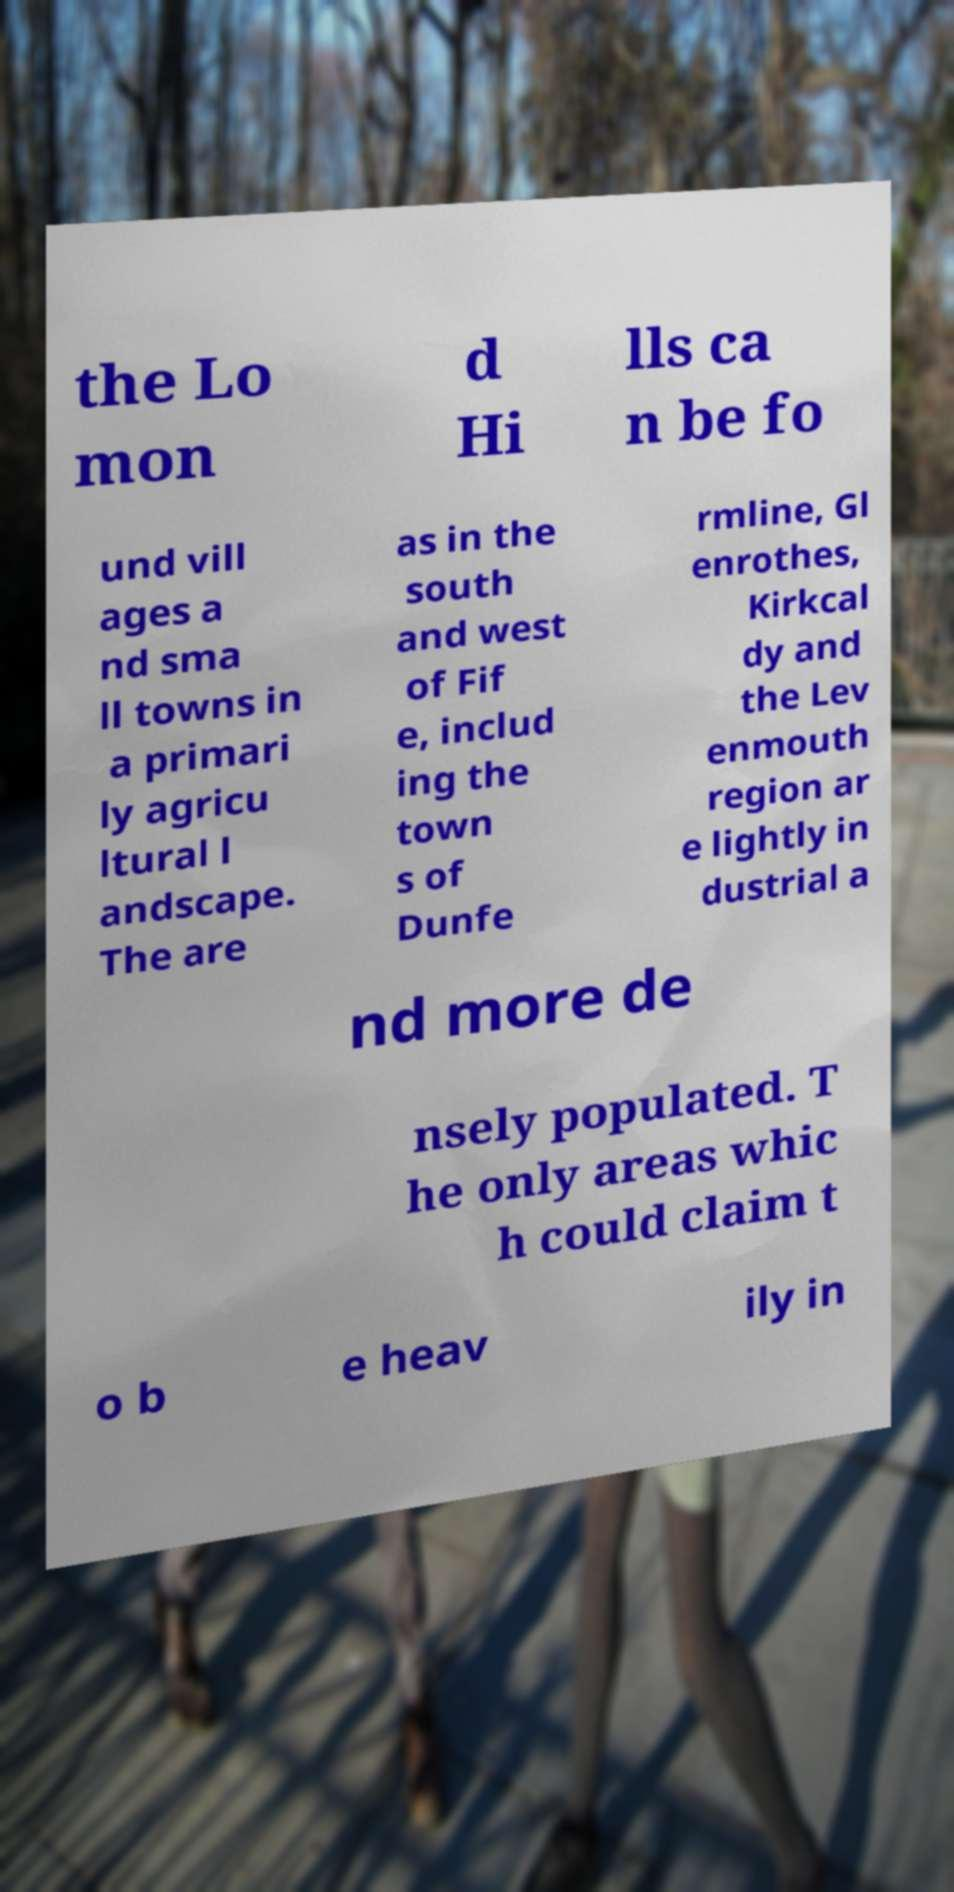For documentation purposes, I need the text within this image transcribed. Could you provide that? the Lo mon d Hi lls ca n be fo und vill ages a nd sma ll towns in a primari ly agricu ltural l andscape. The are as in the south and west of Fif e, includ ing the town s of Dunfe rmline, Gl enrothes, Kirkcal dy and the Lev enmouth region ar e lightly in dustrial a nd more de nsely populated. T he only areas whic h could claim t o b e heav ily in 